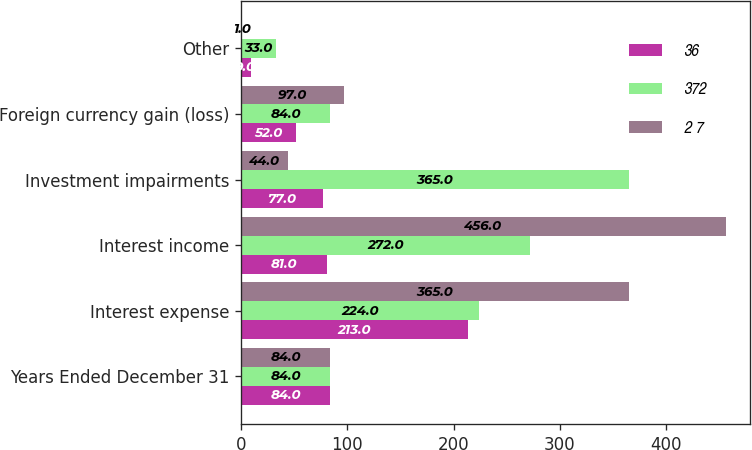<chart> <loc_0><loc_0><loc_500><loc_500><stacked_bar_chart><ecel><fcel>Years Ended December 31<fcel>Interest expense<fcel>Interest income<fcel>Investment impairments<fcel>Foreign currency gain (loss)<fcel>Other<nl><fcel>36<fcel>84<fcel>213<fcel>81<fcel>77<fcel>52<fcel>9<nl><fcel>372<fcel>84<fcel>224<fcel>272<fcel>365<fcel>84<fcel>33<nl><fcel>2 7<fcel>84<fcel>365<fcel>456<fcel>44<fcel>97<fcel>1<nl></chart> 